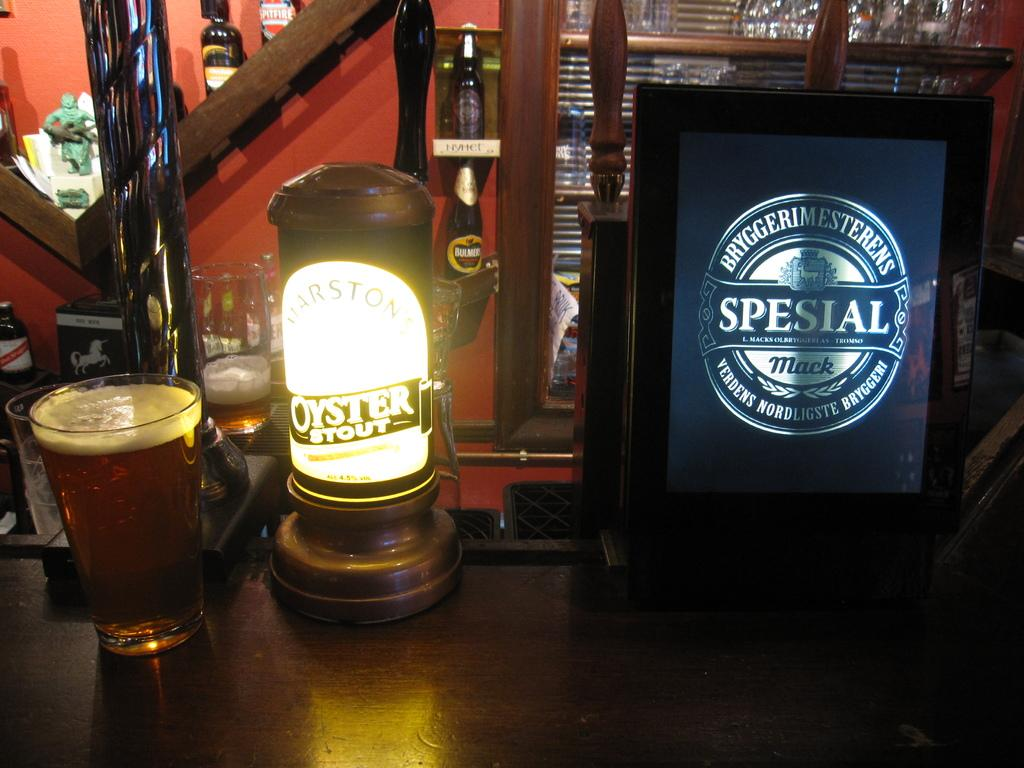<image>
Create a compact narrative representing the image presented. A full glass of beer next to an oyster stout sign. 